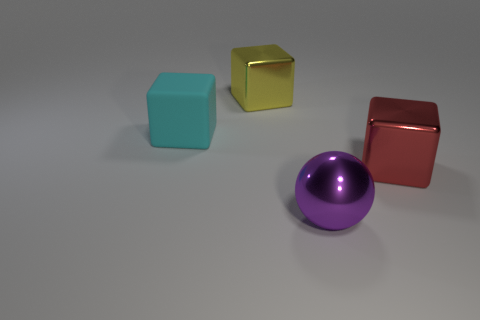Add 2 balls. How many objects exist? 6 Subtract all large metallic blocks. How many blocks are left? 1 Subtract all yellow cubes. How many cubes are left? 2 Subtract 2 cubes. How many cubes are left? 1 Subtract all blocks. How many objects are left? 1 Add 3 red objects. How many red objects are left? 4 Add 2 tiny green matte cylinders. How many tiny green matte cylinders exist? 2 Subtract 0 blue cylinders. How many objects are left? 4 Subtract all cyan spheres. Subtract all yellow cubes. How many spheres are left? 1 Subtract all red cubes. Subtract all large red cubes. How many objects are left? 2 